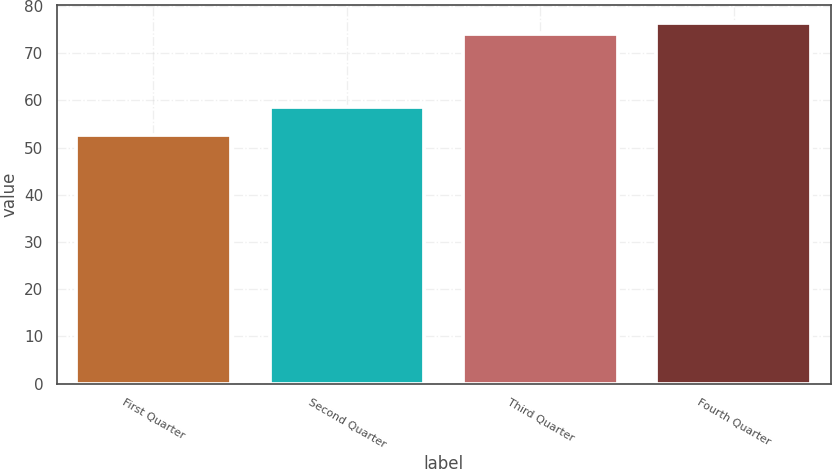<chart> <loc_0><loc_0><loc_500><loc_500><bar_chart><fcel>First Quarter<fcel>Second Quarter<fcel>Third Quarter<fcel>Fourth Quarter<nl><fcel>52.68<fcel>58.55<fcel>73.94<fcel>76.25<nl></chart> 